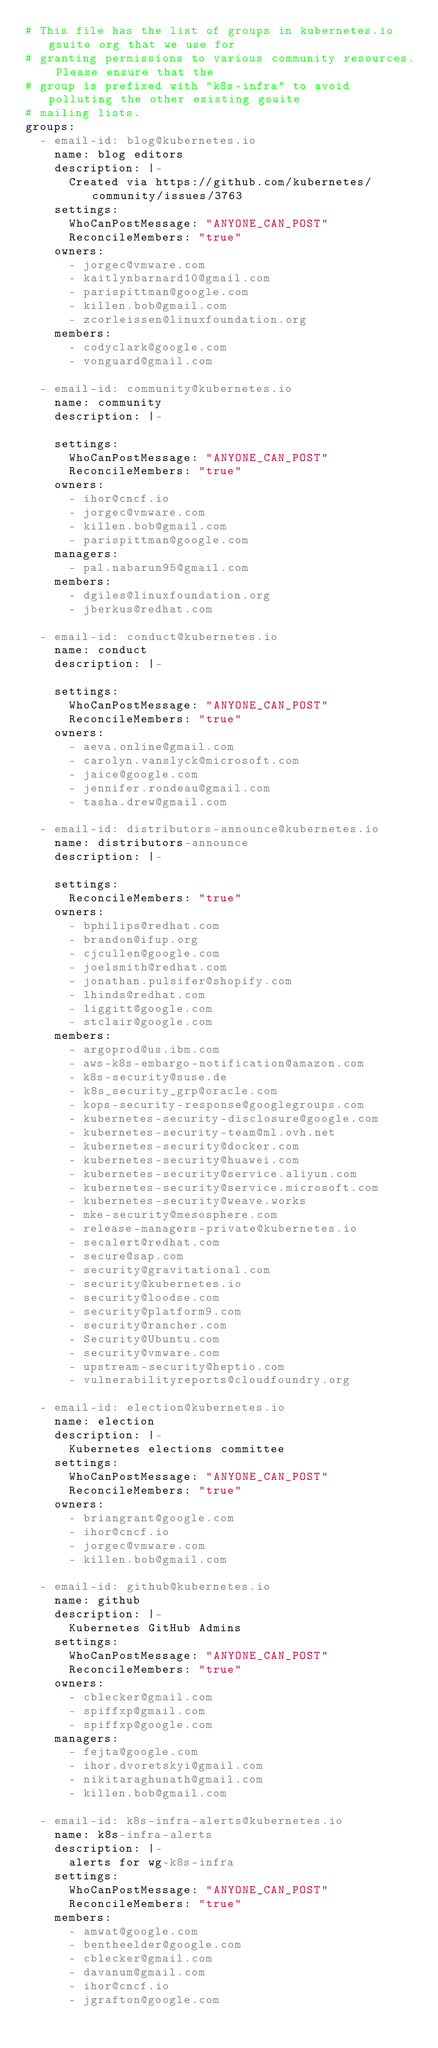Convert code to text. <code><loc_0><loc_0><loc_500><loc_500><_YAML_># This file has the list of groups in kubernetes.io gsuite org that we use for
# granting permissions to various community resources. Please ensure that the
# group is prefixed with "k8s-infra" to avoid polluting the other existing gsuite
# mailing lists.
groups:
  - email-id: blog@kubernetes.io
    name: blog editors
    description: |-
      Created via https://github.com/kubernetes/community/issues/3763
    settings:
      WhoCanPostMessage: "ANYONE_CAN_POST"
      ReconcileMembers: "true"
    owners:
      - jorgec@vmware.com
      - kaitlynbarnard10@gmail.com
      - parispittman@google.com
      - killen.bob@gmail.com
      - zcorleissen@linuxfoundation.org
    members:
      - codyclark@google.com
      - vonguard@gmail.com

  - email-id: community@kubernetes.io
    name: community
    description: |-

    settings:
      WhoCanPostMessage: "ANYONE_CAN_POST"
      ReconcileMembers: "true"
    owners:
      - ihor@cncf.io
      - jorgec@vmware.com
      - killen.bob@gmail.com
      - parispittman@google.com
    managers:
      - pal.nabarun95@gmail.com
    members:
      - dgiles@linuxfoundation.org
      - jberkus@redhat.com

  - email-id: conduct@kubernetes.io
    name: conduct
    description: |-

    settings:
      WhoCanPostMessage: "ANYONE_CAN_POST"
      ReconcileMembers: "true"
    owners:
      - aeva.online@gmail.com
      - carolyn.vanslyck@microsoft.com
      - jaice@google.com
      - jennifer.rondeau@gmail.com
      - tasha.drew@gmail.com

  - email-id: distributors-announce@kubernetes.io
    name: distributors-announce
    description: |-

    settings:
      ReconcileMembers: "true"
    owners:
      - bphilips@redhat.com
      - brandon@ifup.org
      - cjcullen@google.com
      - joelsmith@redhat.com
      - jonathan.pulsifer@shopify.com
      - lhinds@redhat.com
      - liggitt@google.com
      - stclair@google.com
    members:
      - argoprod@us.ibm.com
      - aws-k8s-embargo-notification@amazon.com
      - k8s-security@suse.de
      - k8s_security_grp@oracle.com
      - kops-security-response@googlegroups.com
      - kubernetes-security-disclosure@google.com
      - kubernetes-security-team@ml.ovh.net
      - kubernetes-security@docker.com
      - kubernetes-security@huawei.com
      - kubernetes-security@service.aliyun.com
      - kubernetes-security@service.microsoft.com
      - kubernetes-security@weave.works
      - mke-security@mesosphere.com
      - release-managers-private@kubernetes.io
      - secalert@redhat.com
      - secure@sap.com
      - security@gravitational.com
      - security@kubernetes.io
      - security@loodse.com
      - security@platform9.com
      - security@rancher.com
      - Security@Ubuntu.com
      - security@vmware.com
      - upstream-security@heptio.com
      - vulnerabilityreports@cloudfoundry.org

  - email-id: election@kubernetes.io
    name: election
    description: |-
      Kubernetes elections committee
    settings:
      WhoCanPostMessage: "ANYONE_CAN_POST"
      ReconcileMembers: "true"
    owners:
      - briangrant@google.com
      - ihor@cncf.io
      - jorgec@vmware.com
      - killen.bob@gmail.com

  - email-id: github@kubernetes.io
    name: github
    description: |-
      Kubernetes GitHub Admins
    settings:
      WhoCanPostMessage: "ANYONE_CAN_POST"
      ReconcileMembers: "true"
    owners:
      - cblecker@gmail.com
      - spiffxp@gmail.com
      - spiffxp@google.com
    managers:
      - fejta@google.com
      - ihor.dvoretskyi@gmail.com
      - nikitaraghunath@gmail.com
      - killen.bob@gmail.com

  - email-id: k8s-infra-alerts@kubernetes.io
    name: k8s-infra-alerts
    description: |-
      alerts for wg-k8s-infra
    settings:
      WhoCanPostMessage: "ANYONE_CAN_POST"
      ReconcileMembers: "true"
    members:
      - amwat@google.com
      - bentheelder@google.com
      - cblecker@gmail.com
      - davanum@gmail.com
      - ihor@cncf.io
      - jgrafton@google.com</code> 